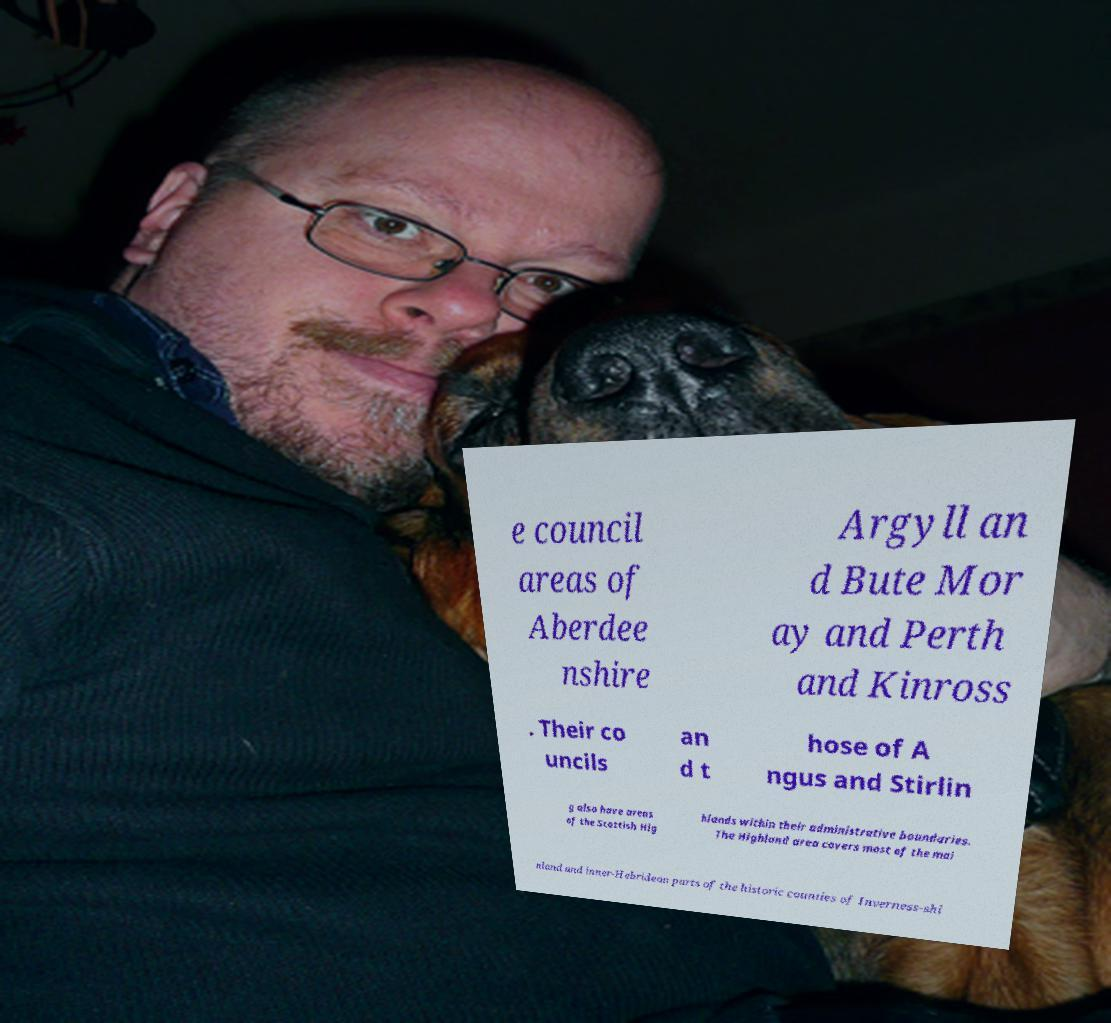Please identify and transcribe the text found in this image. e council areas of Aberdee nshire Argyll an d Bute Mor ay and Perth and Kinross . Their co uncils an d t hose of A ngus and Stirlin g also have areas of the Scottish Hig hlands within their administrative boundaries. The Highland area covers most of the mai nland and inner-Hebridean parts of the historic counties of Inverness-shi 